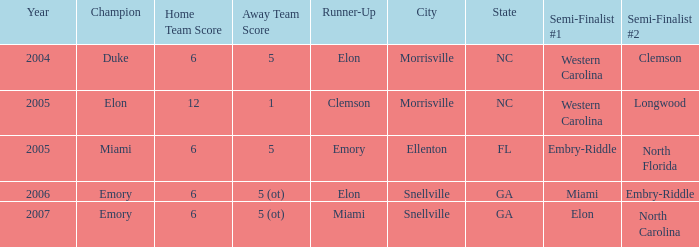List the scores of all games when Miami were listed as the first Semi finalist 6-5 ot. Could you parse the entire table as a dict? {'header': ['Year', 'Champion', 'Home Team Score', 'Away Team Score', 'Runner-Up', 'City', 'State', 'Semi-Finalist #1', 'Semi-Finalist #2'], 'rows': [['2004', 'Duke', '6', '5', 'Elon', 'Morrisville', 'NC', 'Western Carolina', 'Clemson'], ['2005', 'Elon', '12', '1', 'Clemson', 'Morrisville', 'NC', 'Western Carolina', 'Longwood'], ['2005', 'Miami', '6', '5', 'Emory', 'Ellenton', 'FL', 'Embry-Riddle', 'North Florida'], ['2006', 'Emory', '6', '5 (ot)', 'Elon', 'Snellville', 'GA', 'Miami', 'Embry-Riddle'], ['2007', 'Emory', '6', '5 (ot)', 'Miami', 'Snellville', 'GA', 'Elon', 'North Carolina']]} 